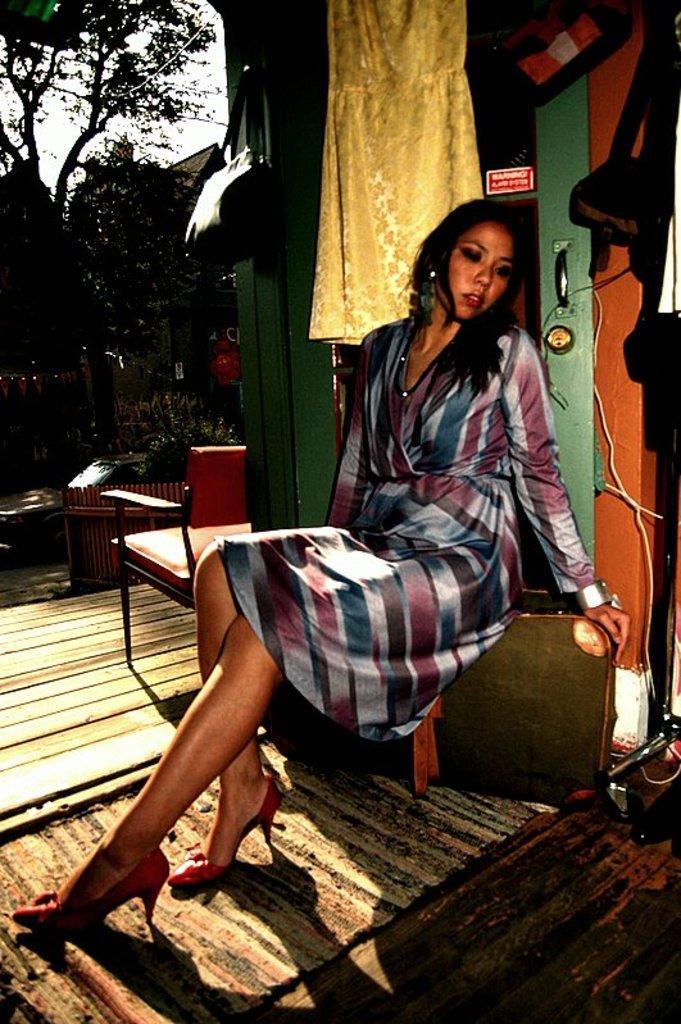Describe this image in one or two sentences. In the picture we can see a woman sitting on the stool, beside her there is a chair, railing, plants, trees and sky, behind there is a door which is green in color with handle and a dress placed on the door and some things kept beside it and floor mat is kept on the floor. 